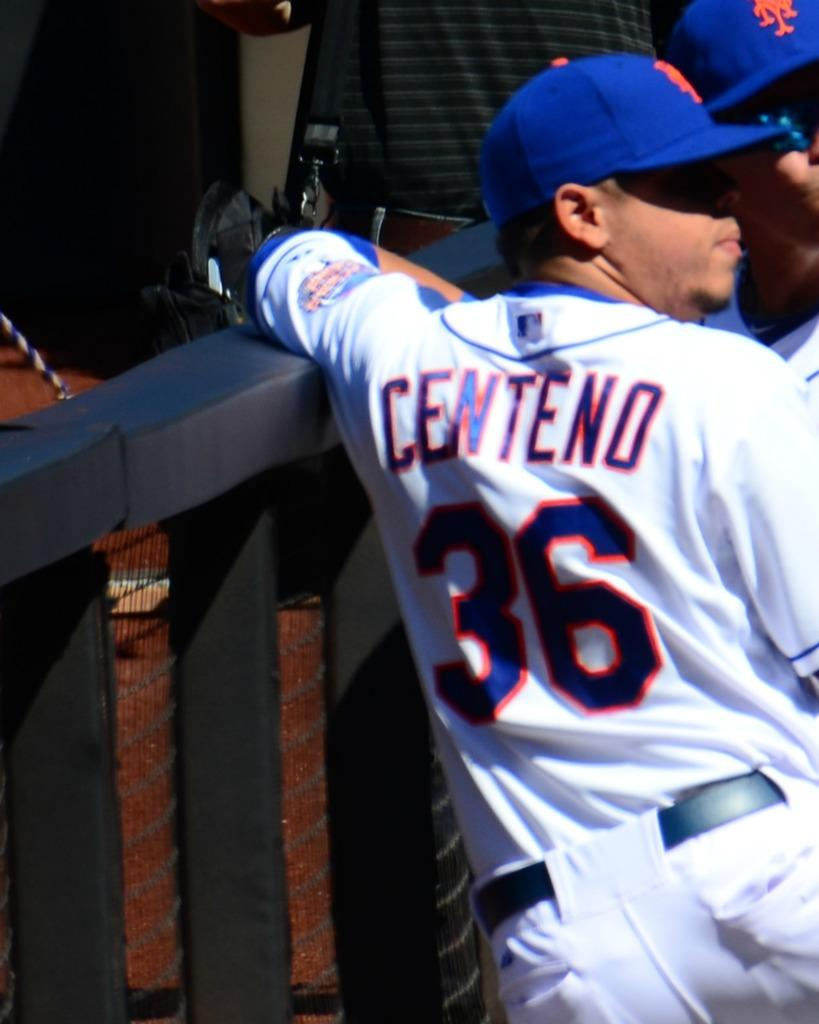<image>
Describe the image concisely. Baseball player Centeno wears jersey number 36 for the New York Mets. 